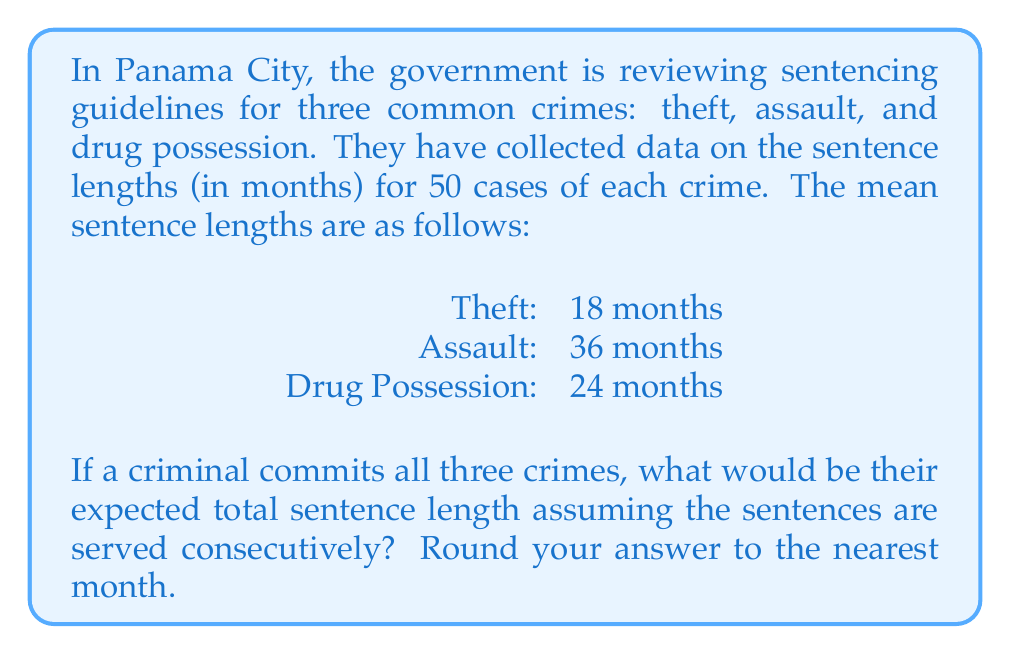Show me your answer to this math problem. To solve this problem, we need to follow these steps:

1. Understand the given information:
   - We have mean sentence lengths for three crimes:
     Theft: 18 months
     Assault: 36 months
     Drug Possession: 24 months

2. Calculate the total expected sentence length:
   - Since the sentences are served consecutively (one after another), we need to add the mean sentence lengths for all three crimes.
   
   $$ \text{Total Expected Sentence} = \text{Theft} + \text{Assault} + \text{Drug Possession} $$
   $$ \text{Total Expected Sentence} = 18 + 36 + 24 $$
   $$ \text{Total Expected Sentence} = 78 \text{ months} $$

3. Round the result to the nearest month:
   - The result is already a whole number, so no rounding is necessary.

Therefore, the expected total sentence length for committing all three crimes is 78 months.
Answer: 78 months 